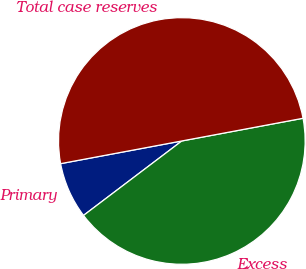Convert chart to OTSL. <chart><loc_0><loc_0><loc_500><loc_500><pie_chart><fcel>Primary<fcel>Excess<fcel>Total case reserves<nl><fcel>7.37%<fcel>42.63%<fcel>50.0%<nl></chart> 